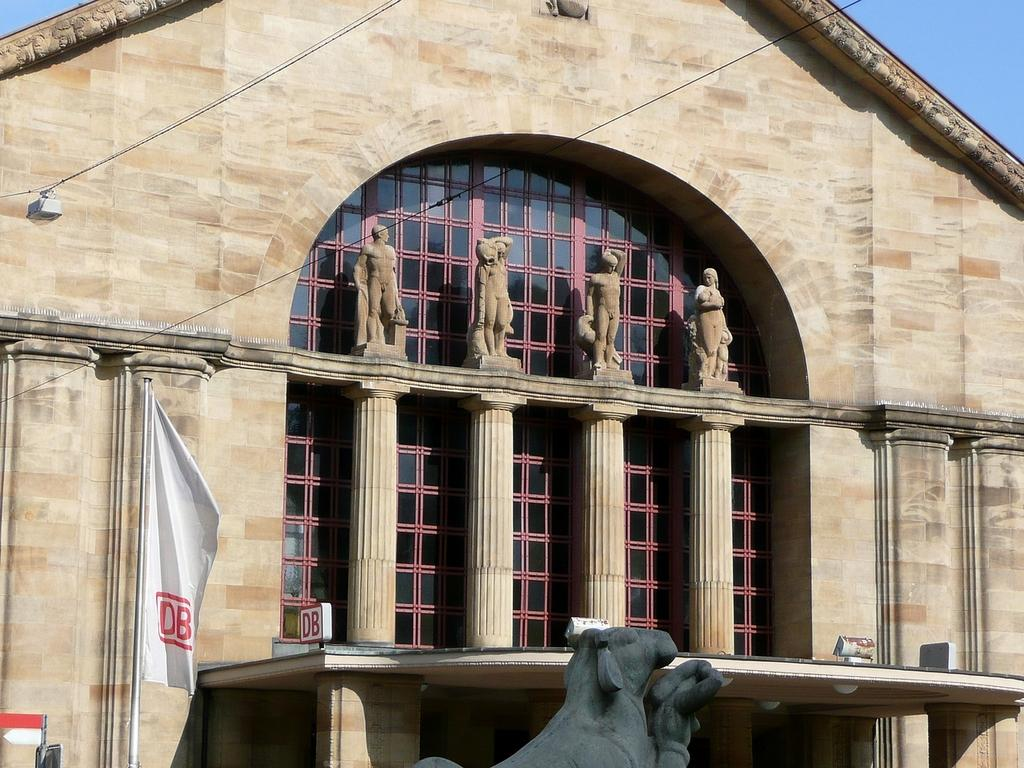What type of structure is present in the image? There is a house in the image. What are some features of the house? The house has a roof, pillars, statues, and windows. Are there any other objects visible in the image? Yes, there are wires and the sky visible in the image. What can be seen at the bottom of the image? There is a statue and a flag at the bottom of the image. Who is the owner of the house in the image? There is no information about the owner of the house in the image. Is there a fire visible in the image? No, there is no fire visible in the image. Can you see any account information in the image? No, there is no account information visible in the image. 